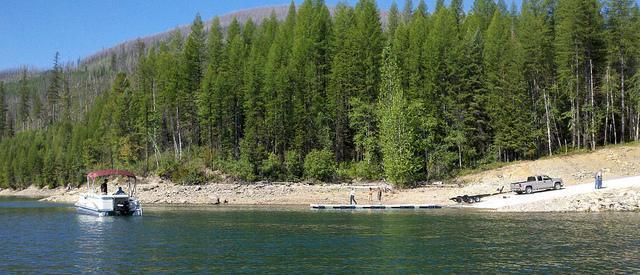How many donuts are there?
Give a very brief answer. 0. 